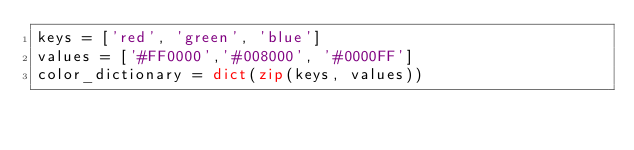Convert code to text. <code><loc_0><loc_0><loc_500><loc_500><_Python_>keys = ['red', 'green', 'blue']
values = ['#FF0000','#008000', '#0000FF']
color_dictionary = dict(zip(keys, values))</code> 